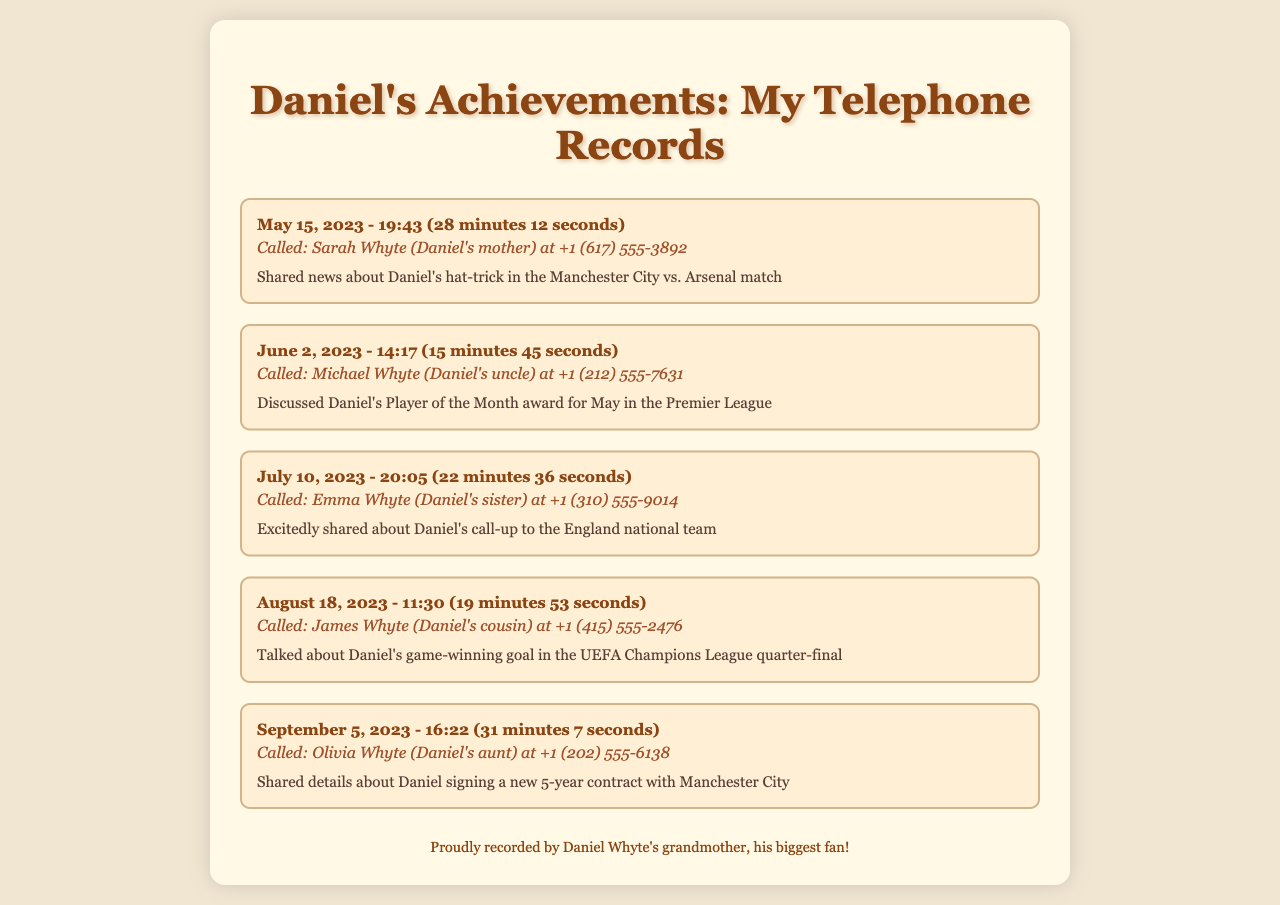What date did Daniel score a hat-trick? The date when Daniel scored a hat-trick is mentioned in the call to Sarah Whyte.
Answer: May 15, 2023 Who did Daniel call about his Player of the Month award? The call concerning Daniel's Player of the Month award was made to his uncle, Michael.
Answer: Michael Whyte How long was the call discussing Daniel's call-up to the national team? The duration of the call about Daniel's national team call-up is detailed in the record with Emma Whyte.
Answer: 22 minutes 36 seconds What achievement was shared with Olivia Whyte? The call with Olivia discussed a significant achievement related to Daniel's contract.
Answer: Signing a new 5-year contract Which family member received the news about Daniel's game-winning goal? The news about Daniel's game-winning goal was shared with his cousin, James.
Answer: James Whyte What time was the call made to discuss Daniel's hat-trick? The time for the call to Sarah about the hat-trick is specified in the document.
Answer: 19:43 Who is the proud record keeper of these telephone records? The identity of the person recording the telephone records, who is also a fan, is mentioned at the end.
Answer: Daniel Whyte's grandmother How many calls are recorded in total? The total number of recorded calls related to Daniel's achievements is reflected in the entries.
Answer: Five 